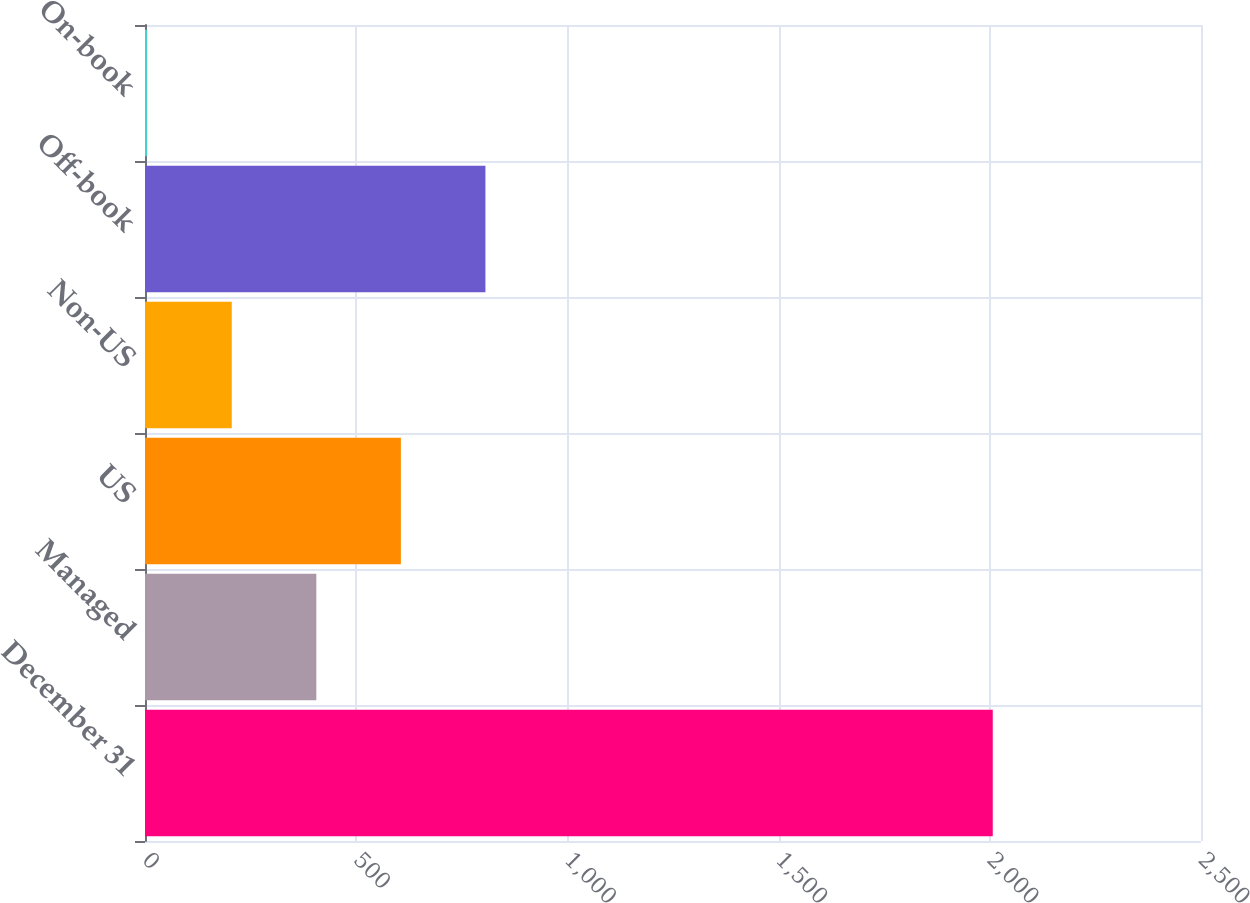Convert chart. <chart><loc_0><loc_0><loc_500><loc_500><bar_chart><fcel>December 31<fcel>Managed<fcel>US<fcel>Non-US<fcel>Off-book<fcel>On-book<nl><fcel>2007<fcel>405.58<fcel>605.76<fcel>205.4<fcel>805.94<fcel>5.22<nl></chart> 